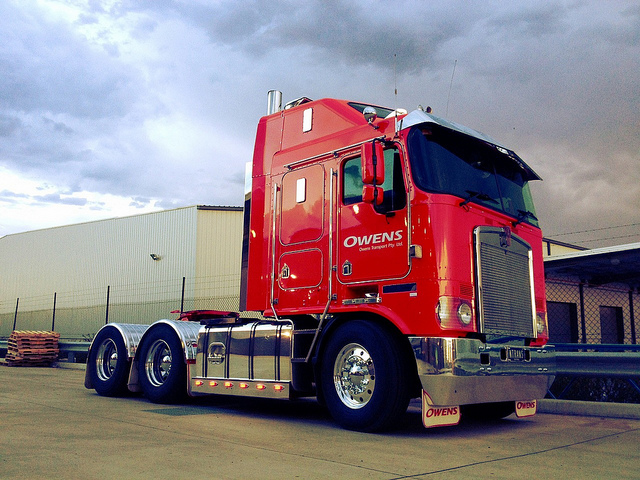Please extract the text content from this image. OWENS OWENS 